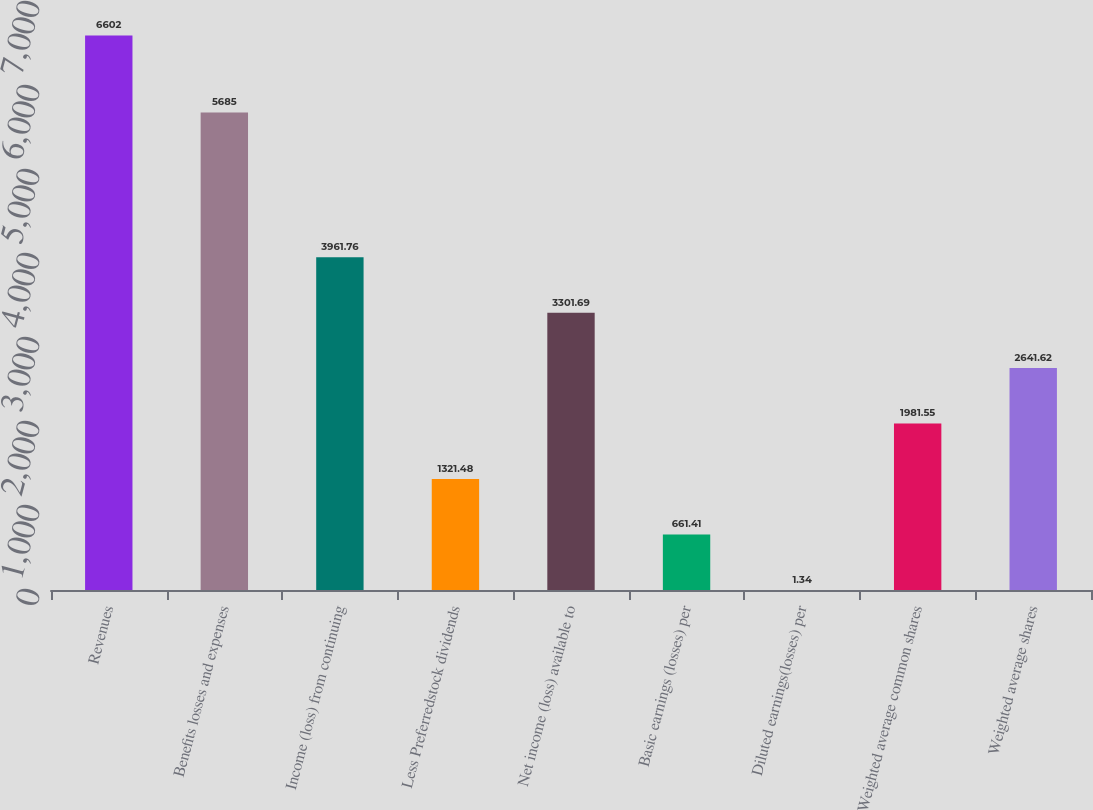Convert chart. <chart><loc_0><loc_0><loc_500><loc_500><bar_chart><fcel>Revenues<fcel>Benefits losses and expenses<fcel>Income (loss) from continuing<fcel>Less Preferredstock dividends<fcel>Net income (loss) available to<fcel>Basic earnings (losses) per<fcel>Diluted earnings(losses) per<fcel>Weighted average common shares<fcel>Weighted average shares<nl><fcel>6602<fcel>5685<fcel>3961.76<fcel>1321.48<fcel>3301.69<fcel>661.41<fcel>1.34<fcel>1981.55<fcel>2641.62<nl></chart> 